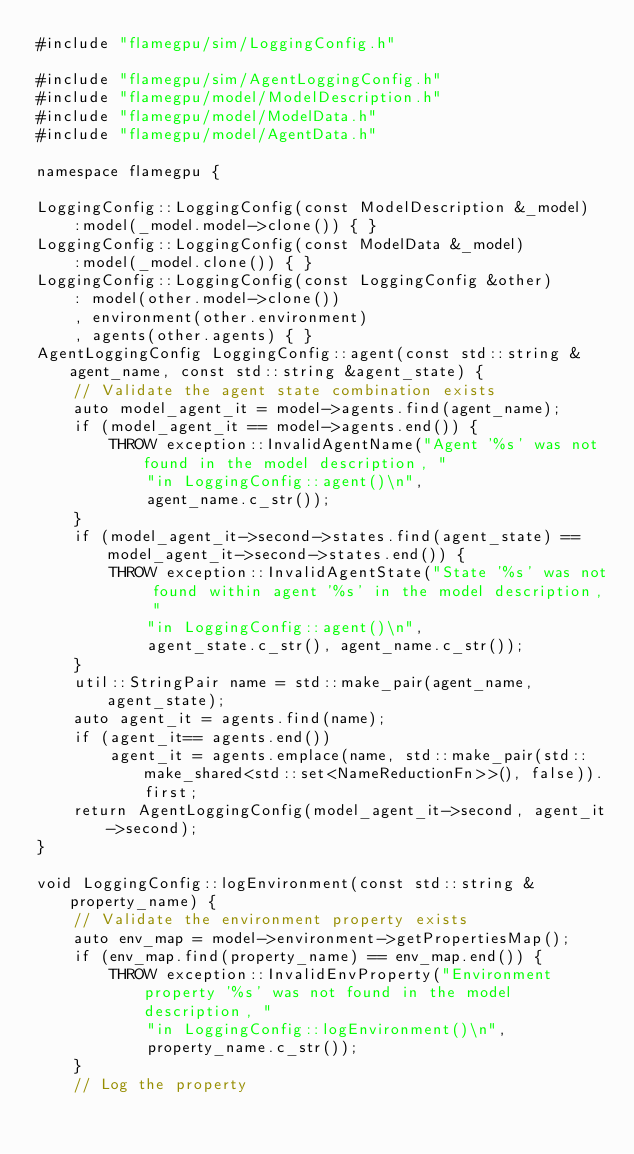<code> <loc_0><loc_0><loc_500><loc_500><_Cuda_>#include "flamegpu/sim/LoggingConfig.h"

#include "flamegpu/sim/AgentLoggingConfig.h"
#include "flamegpu/model/ModelDescription.h"
#include "flamegpu/model/ModelData.h"
#include "flamegpu/model/AgentData.h"

namespace flamegpu {

LoggingConfig::LoggingConfig(const ModelDescription &_model)
    :model(_model.model->clone()) { }
LoggingConfig::LoggingConfig(const ModelData &_model)
    :model(_model.clone()) { }
LoggingConfig::LoggingConfig(const LoggingConfig &other)
    : model(other.model->clone())
    , environment(other.environment)
    , agents(other.agents) { }
AgentLoggingConfig LoggingConfig::agent(const std::string &agent_name, const std::string &agent_state) {
    // Validate the agent state combination exists
    auto model_agent_it = model->agents.find(agent_name);
    if (model_agent_it == model->agents.end()) {
        THROW exception::InvalidAgentName("Agent '%s' was not found in the model description, "
            "in LoggingConfig::agent()\n",
            agent_name.c_str());
    }
    if (model_agent_it->second->states.find(agent_state) == model_agent_it->second->states.end()) {
        THROW exception::InvalidAgentState("State '%s' was not found within agent '%s' in the model description, "
            "in LoggingConfig::agent()\n",
            agent_state.c_str(), agent_name.c_str());
    }
    util::StringPair name = std::make_pair(agent_name, agent_state);
    auto agent_it = agents.find(name);
    if (agent_it== agents.end())
        agent_it = agents.emplace(name, std::make_pair(std::make_shared<std::set<NameReductionFn>>(), false)).first;
    return AgentLoggingConfig(model_agent_it->second, agent_it->second);
}

void LoggingConfig::logEnvironment(const std::string &property_name) {
    // Validate the environment property exists
    auto env_map = model->environment->getPropertiesMap();
    if (env_map.find(property_name) == env_map.end()) {
        THROW exception::InvalidEnvProperty("Environment property '%s' was not found in the model description, "
            "in LoggingConfig::logEnvironment()\n",
            property_name.c_str());
    }
    // Log the property</code> 